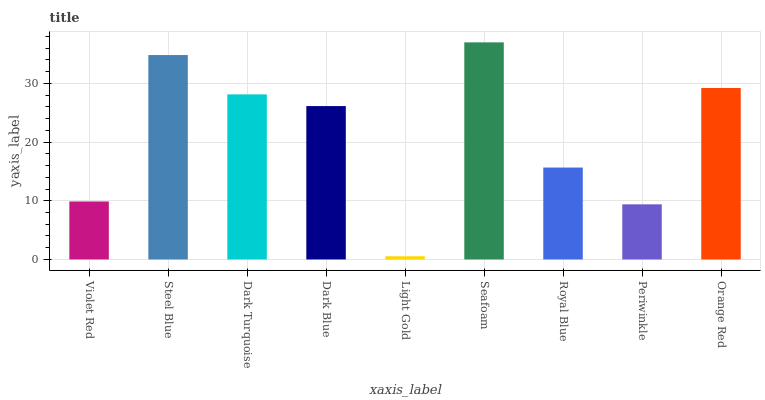Is Steel Blue the minimum?
Answer yes or no. No. Is Steel Blue the maximum?
Answer yes or no. No. Is Steel Blue greater than Violet Red?
Answer yes or no. Yes. Is Violet Red less than Steel Blue?
Answer yes or no. Yes. Is Violet Red greater than Steel Blue?
Answer yes or no. No. Is Steel Blue less than Violet Red?
Answer yes or no. No. Is Dark Blue the high median?
Answer yes or no. Yes. Is Dark Blue the low median?
Answer yes or no. Yes. Is Light Gold the high median?
Answer yes or no. No. Is Royal Blue the low median?
Answer yes or no. No. 